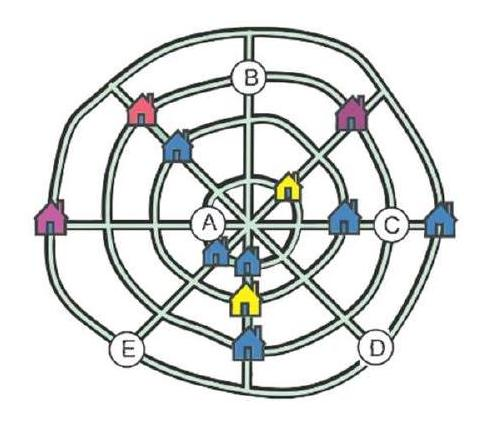Could there be any cultural significance to the way the houses are arranged? While we can't determine cultural significance from the layout alone, it's possible that the symmetrical and orderly configuration of the houses suggests a community valuing structure and equality. Perhaps the design facilitates neighborly interaction or reflects a traditional style that has been maintained for cultural reasons. It would require further context about the village's origins and inhabitants to form a more accurate assessment. 